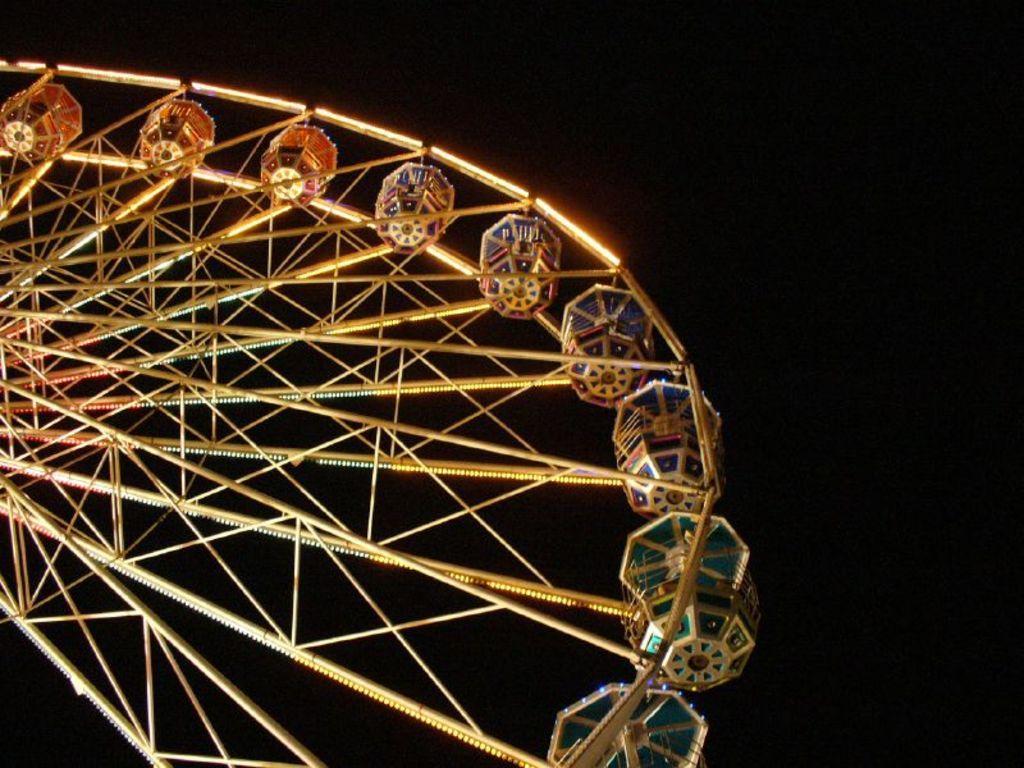Could you give a brief overview of what you see in this image? In this picture we can see a joint wheel and in the background it is dark. 